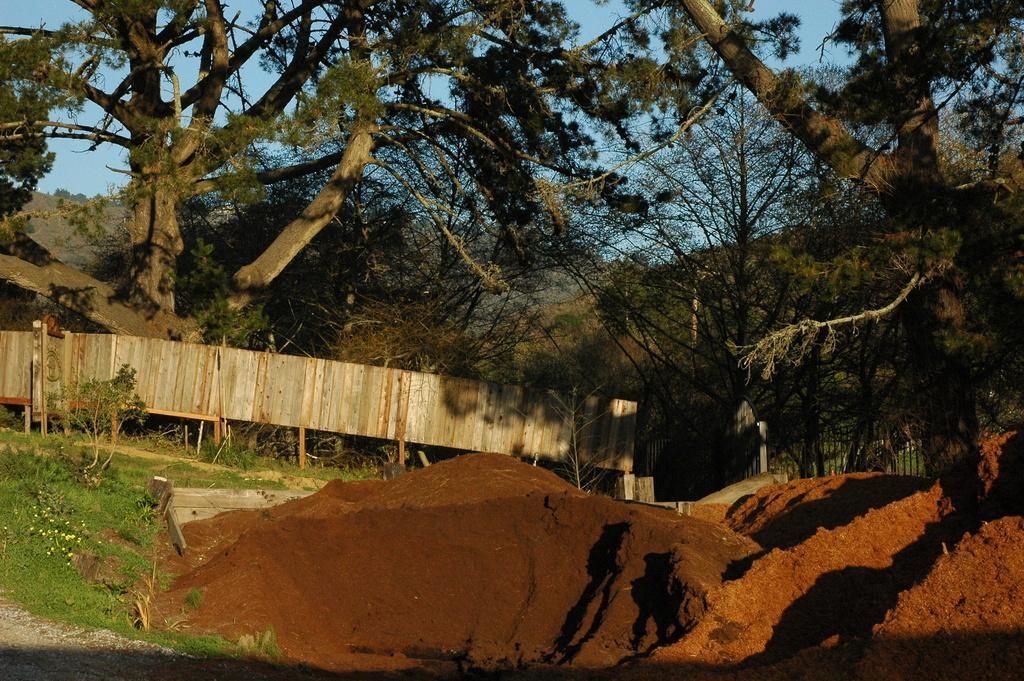Describe this image in one or two sentences. In this image we can see the red soil. And we can see the grass. And we can see the wood fence. And we can see the trees. And we can see the hills. And in the background we can see the sky. 